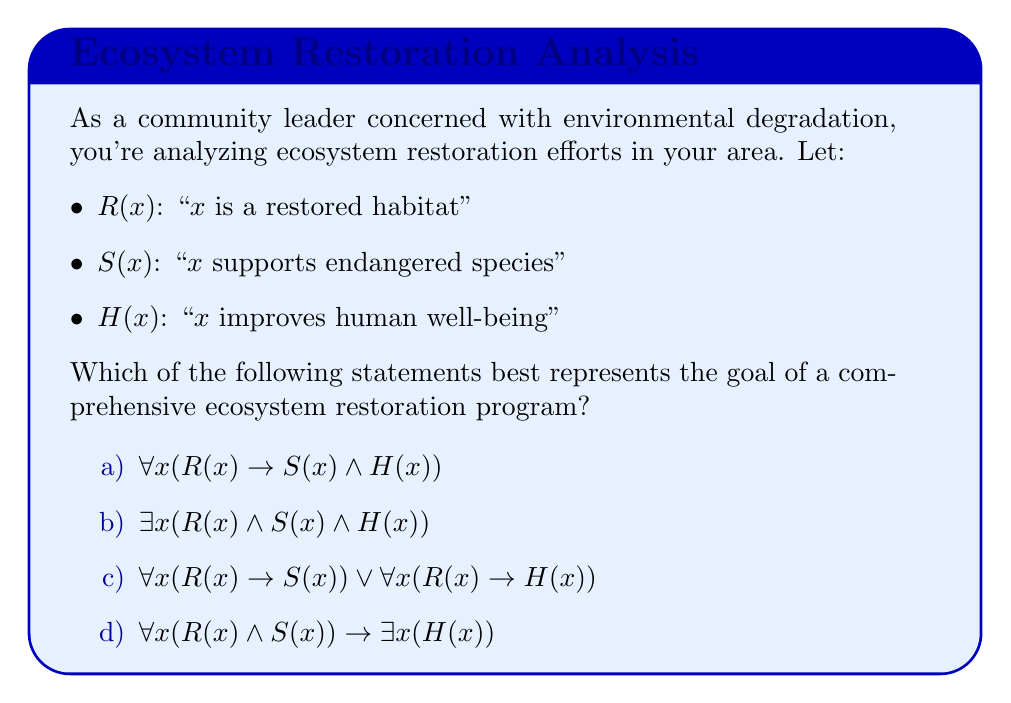Can you answer this question? Let's analyze each option:

a) $\forall x(R(x) \rightarrow S(x) \wedge H(x))$
   This statement reads: "For all x, if x is a restored habitat, then x supports endangered species and improves human well-being."
   
b) $\exists x(R(x) \wedge S(x) \wedge H(x))$
   This statement reads: "There exists an x such that x is a restored habitat, supports endangered species, and improves human well-being."
   
c) $\forall x(R(x) \rightarrow S(x)) \vee \forall x(R(x) \rightarrow H(x))$
   This statement reads: "For all x, if x is a restored habitat, then x supports endangered species, OR for all x, if x is a restored habitat, then x improves human well-being."
   
d) $\forall x(R(x) \wedge S(x)) \rightarrow \exists x(H(x))$
   This statement reads: "If for all x, x is a restored habitat and supports endangered species, then there exists an x that improves human well-being."

A comprehensive ecosystem restoration program would aim to ensure that all restored habitats both support endangered species and improve human well-being. This is best represented by option (a).

Option (b) only requires the existence of one habitat meeting all criteria, which is not comprehensive.
Option (c) allows for habitats to meet either criterion but not necessarily both, which is not ideal.
Option (d) doesn't ensure that all restored habitats improve human well-being, only that if all support endangered species, then at least one improves human well-being.

Therefore, option (a) $\forall x(R(x) \rightarrow S(x) \wedge H(x))$ is the most appropriate representation of a comprehensive ecosystem restoration program's goal.
Answer: a) $\forall x(R(x) \rightarrow S(x) \wedge H(x))$ 